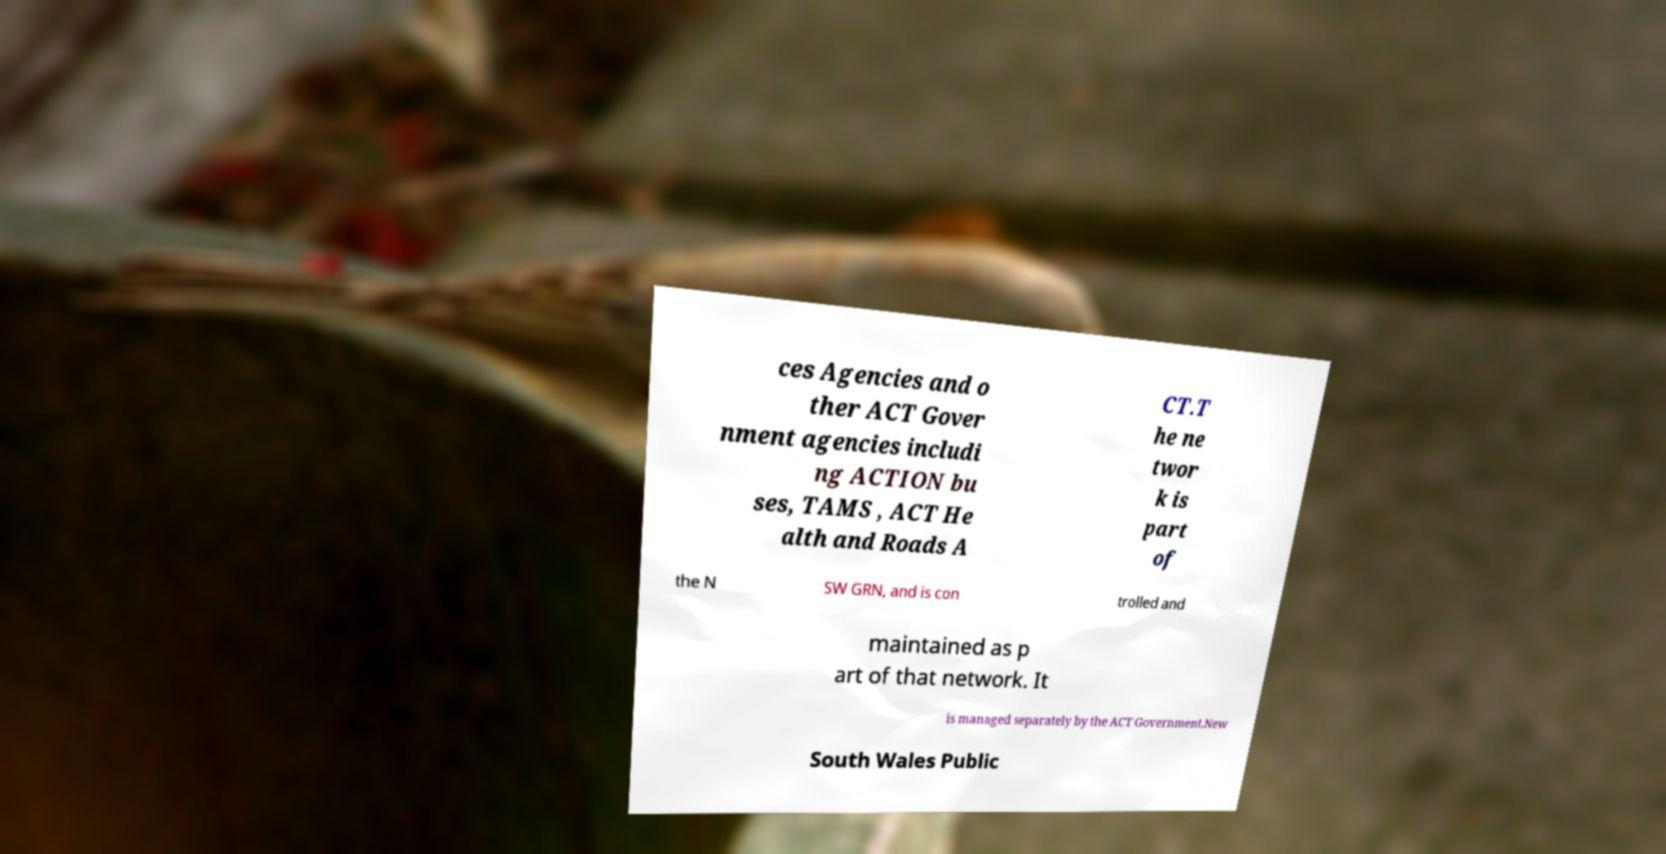What messages or text are displayed in this image? I need them in a readable, typed format. ces Agencies and o ther ACT Gover nment agencies includi ng ACTION bu ses, TAMS , ACT He alth and Roads A CT.T he ne twor k is part of the N SW GRN, and is con trolled and maintained as p art of that network. It is managed separately by the ACT Government.New South Wales Public 